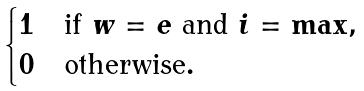Convert formula to latex. <formula><loc_0><loc_0><loc_500><loc_500>\begin{cases} 1 & \text {if $w=e$ and $i=\max$} , \\ 0 & \text {otherwise} . \end{cases}</formula> 